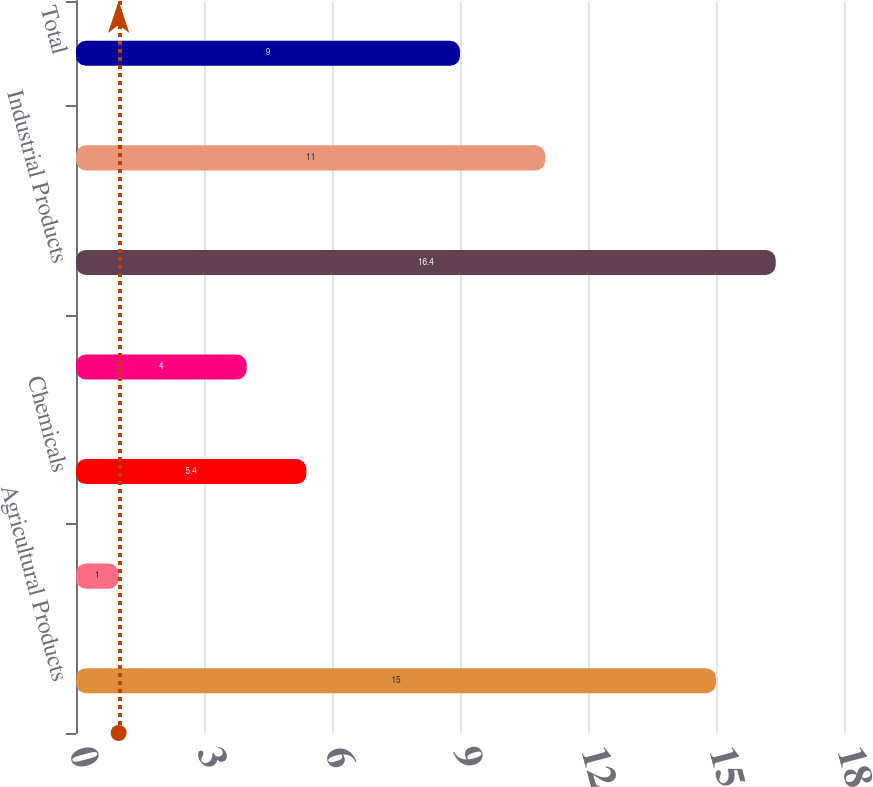Convert chart to OTSL. <chart><loc_0><loc_0><loc_500><loc_500><bar_chart><fcel>Agricultural Products<fcel>Automotive<fcel>Chemicals<fcel>Coal<fcel>Industrial Products<fcel>Intermodal<fcel>Total<nl><fcel>15<fcel>1<fcel>5.4<fcel>4<fcel>16.4<fcel>11<fcel>9<nl></chart> 